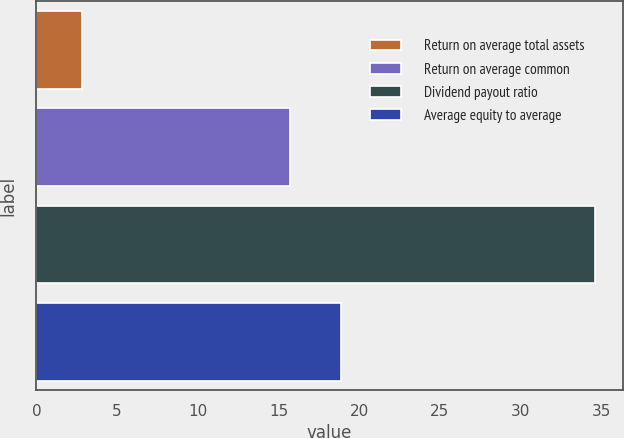<chart> <loc_0><loc_0><loc_500><loc_500><bar_chart><fcel>Return on average total assets<fcel>Return on average common<fcel>Dividend payout ratio<fcel>Average equity to average<nl><fcel>2.83<fcel>15.69<fcel>34.58<fcel>18.86<nl></chart> 